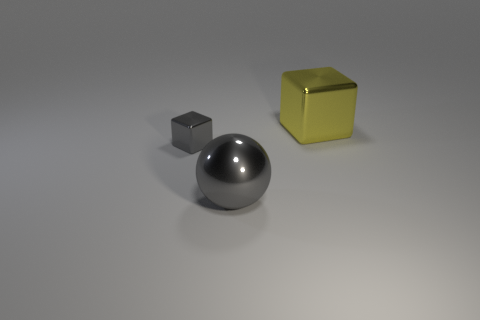Is there anything else that has the same shape as the big gray object?
Your response must be concise. No. Is there anything else of the same color as the large metallic block?
Your response must be concise. No. What number of things are things to the left of the yellow block or blocks that are right of the large sphere?
Provide a short and direct response. 3. The thing that is both behind the gray shiny sphere and on the right side of the gray cube has what shape?
Keep it short and to the point. Cube. What number of gray spheres are right of the shiny cube that is to the right of the small gray object?
Your response must be concise. 0. What number of objects are gray metallic things that are right of the tiny shiny object or shiny objects?
Keep it short and to the point. 3. There is a metal thing in front of the tiny gray thing; what is its size?
Give a very brief answer. Large. The gray thing that is on the right side of the shiny cube in front of the big yellow thing is what shape?
Keep it short and to the point. Sphere. How many other things are the same shape as the tiny gray shiny thing?
Offer a terse response. 1. There is a large gray metallic object; are there any yellow metallic cubes to the left of it?
Give a very brief answer. No. 